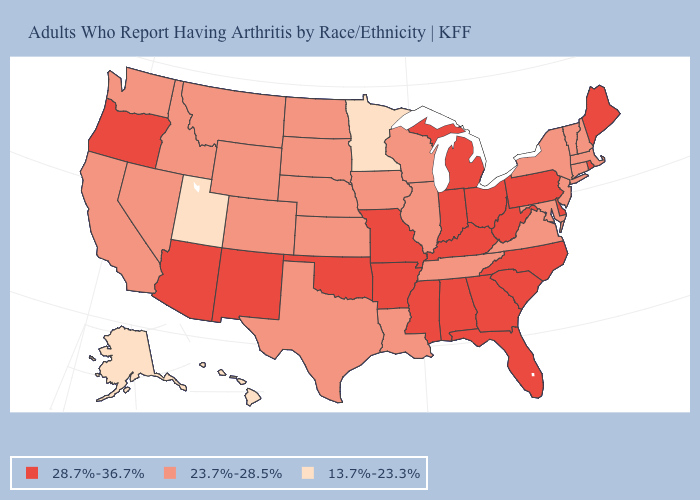Among the states that border South Carolina , which have the lowest value?
Be succinct. Georgia, North Carolina. Which states hav the highest value in the MidWest?
Give a very brief answer. Indiana, Michigan, Missouri, Ohio. Does the map have missing data?
Keep it brief. No. Is the legend a continuous bar?
Keep it brief. No. What is the value of Hawaii?
Quick response, please. 13.7%-23.3%. Does the map have missing data?
Give a very brief answer. No. What is the value of Indiana?
Short answer required. 28.7%-36.7%. What is the value of Idaho?
Give a very brief answer. 23.7%-28.5%. Does New Jersey have the highest value in the USA?
Short answer required. No. Among the states that border Ohio , which have the lowest value?
Short answer required. Indiana, Kentucky, Michigan, Pennsylvania, West Virginia. Name the states that have a value in the range 23.7%-28.5%?
Short answer required. California, Colorado, Connecticut, Idaho, Illinois, Iowa, Kansas, Louisiana, Maryland, Massachusetts, Montana, Nebraska, Nevada, New Hampshire, New Jersey, New York, North Dakota, South Dakota, Tennessee, Texas, Vermont, Virginia, Washington, Wisconsin, Wyoming. Does Oregon have the same value as North Carolina?
Concise answer only. Yes. What is the value of Vermont?
Short answer required. 23.7%-28.5%. What is the value of Colorado?
Quick response, please. 23.7%-28.5%. Which states have the highest value in the USA?
Quick response, please. Alabama, Arizona, Arkansas, Delaware, Florida, Georgia, Indiana, Kentucky, Maine, Michigan, Mississippi, Missouri, New Mexico, North Carolina, Ohio, Oklahoma, Oregon, Pennsylvania, Rhode Island, South Carolina, West Virginia. 